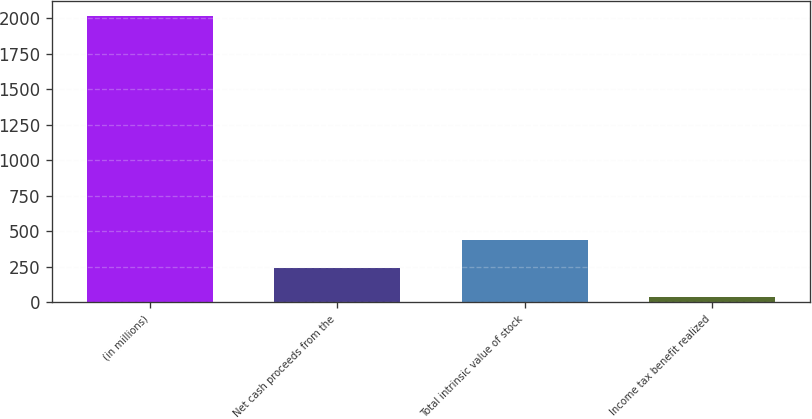<chart> <loc_0><loc_0><loc_500><loc_500><bar_chart><fcel>(in millions)<fcel>Net cash proceeds from the<fcel>Total intrinsic value of stock<fcel>Income tax benefit realized<nl><fcel>2016<fcel>238.5<fcel>436<fcel>41<nl></chart> 